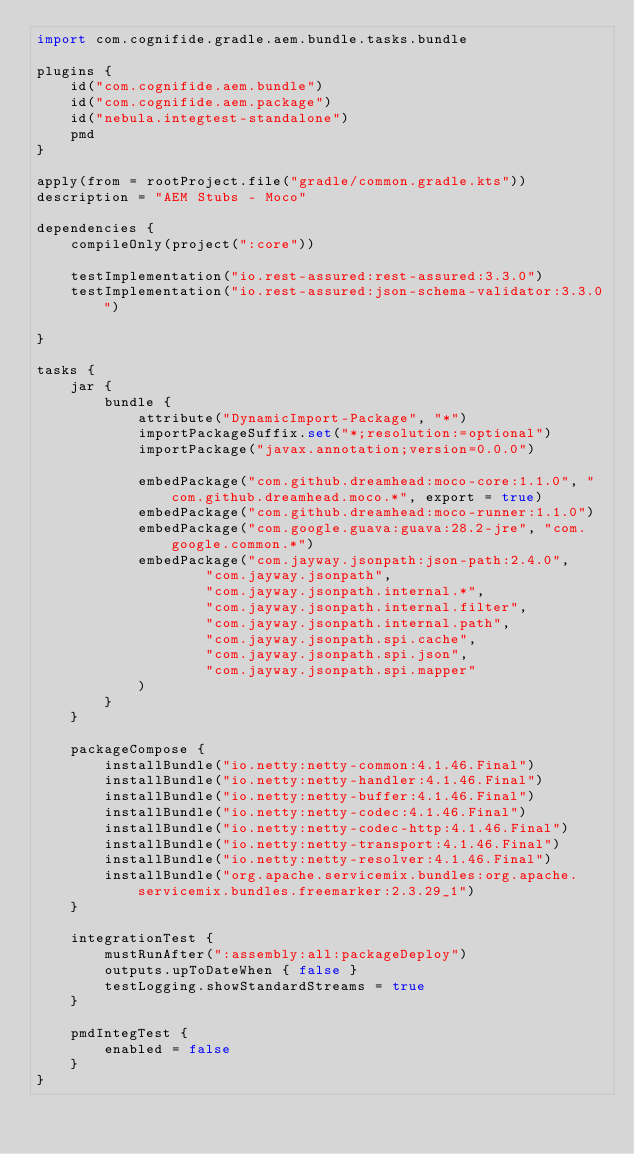Convert code to text. <code><loc_0><loc_0><loc_500><loc_500><_Kotlin_>import com.cognifide.gradle.aem.bundle.tasks.bundle

plugins {
    id("com.cognifide.aem.bundle")
    id("com.cognifide.aem.package")
    id("nebula.integtest-standalone")
    pmd
}

apply(from = rootProject.file("gradle/common.gradle.kts"))
description = "AEM Stubs - Moco"

dependencies {
    compileOnly(project(":core"))

    testImplementation("io.rest-assured:rest-assured:3.3.0")
    testImplementation("io.rest-assured:json-schema-validator:3.3.0")

}

tasks {
    jar {
        bundle {
            attribute("DynamicImport-Package", "*")
            importPackageSuffix.set("*;resolution:=optional")
            importPackage("javax.annotation;version=0.0.0")

            embedPackage("com.github.dreamhead:moco-core:1.1.0", "com.github.dreamhead.moco.*", export = true)
            embedPackage("com.github.dreamhead:moco-runner:1.1.0")
            embedPackage("com.google.guava:guava:28.2-jre", "com.google.common.*")
            embedPackage("com.jayway.jsonpath:json-path:2.4.0",
                    "com.jayway.jsonpath",
                    "com.jayway.jsonpath.internal.*",
                    "com.jayway.jsonpath.internal.filter",
                    "com.jayway.jsonpath.internal.path",
                    "com.jayway.jsonpath.spi.cache",
                    "com.jayway.jsonpath.spi.json",
                    "com.jayway.jsonpath.spi.mapper"
            )
        }
    }

    packageCompose {
        installBundle("io.netty:netty-common:4.1.46.Final")
        installBundle("io.netty:netty-handler:4.1.46.Final")
        installBundle("io.netty:netty-buffer:4.1.46.Final")
        installBundle("io.netty:netty-codec:4.1.46.Final")
        installBundle("io.netty:netty-codec-http:4.1.46.Final")
        installBundle("io.netty:netty-transport:4.1.46.Final")
        installBundle("io.netty:netty-resolver:4.1.46.Final")
        installBundle("org.apache.servicemix.bundles:org.apache.servicemix.bundles.freemarker:2.3.29_1")
    }

    integrationTest {
        mustRunAfter(":assembly:all:packageDeploy")
        outputs.upToDateWhen { false }
        testLogging.showStandardStreams = true
    }

    pmdIntegTest {
        enabled = false
    }
}
</code> 